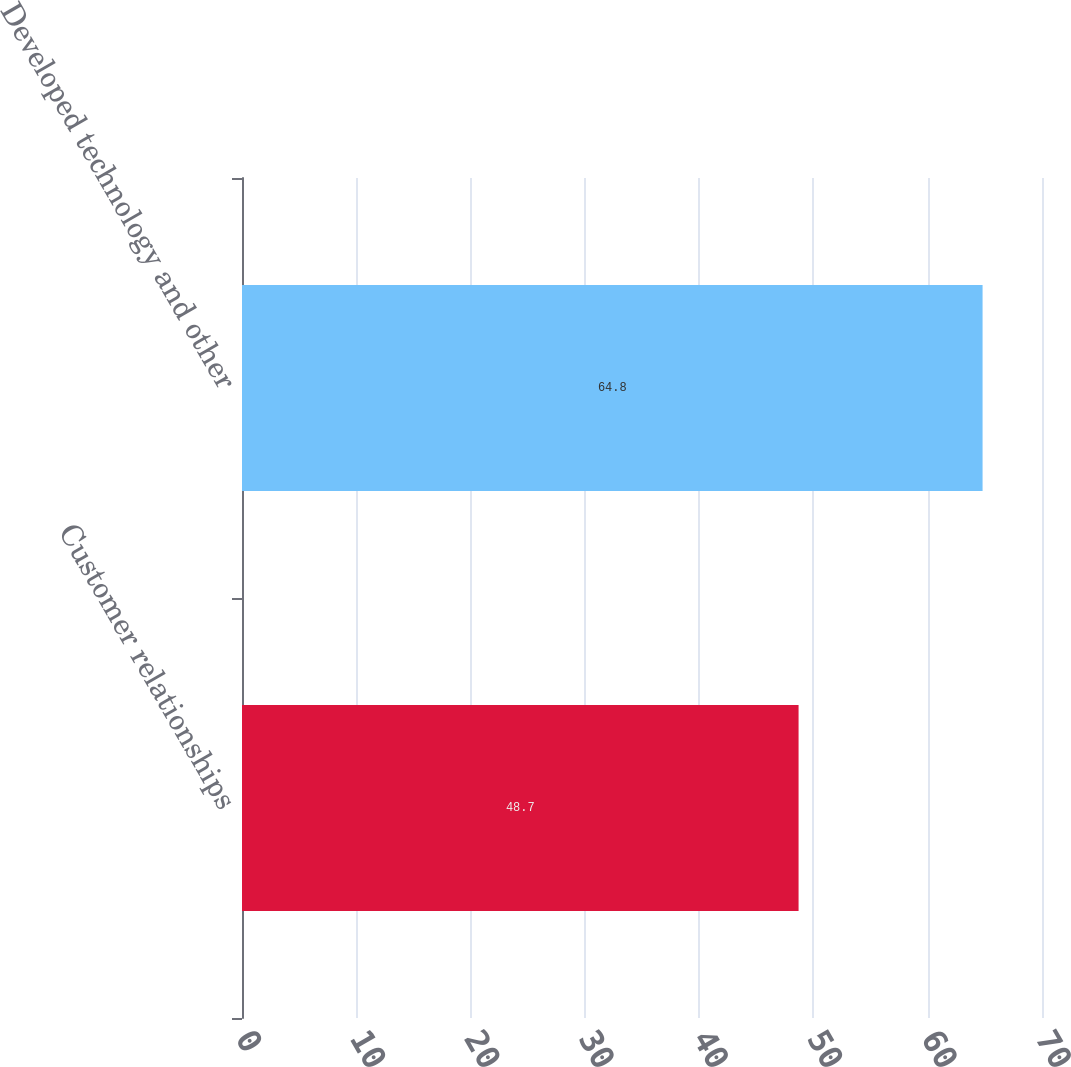Convert chart to OTSL. <chart><loc_0><loc_0><loc_500><loc_500><bar_chart><fcel>Customer relationships<fcel>Developed technology and other<nl><fcel>48.7<fcel>64.8<nl></chart> 